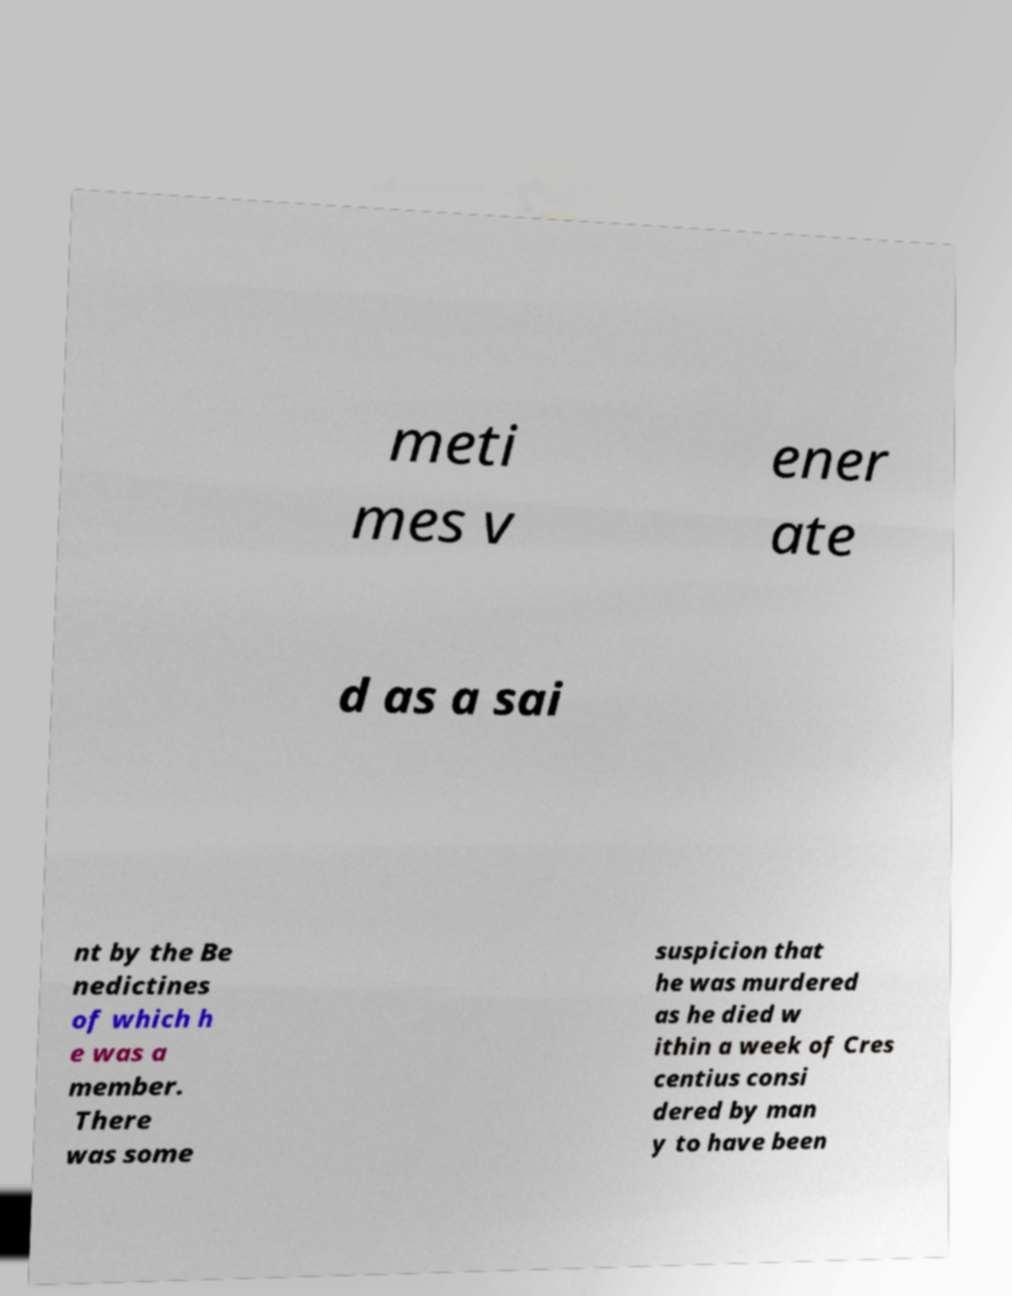Please read and relay the text visible in this image. What does it say? meti mes v ener ate d as a sai nt by the Be nedictines of which h e was a member. There was some suspicion that he was murdered as he died w ithin a week of Cres centius consi dered by man y to have been 